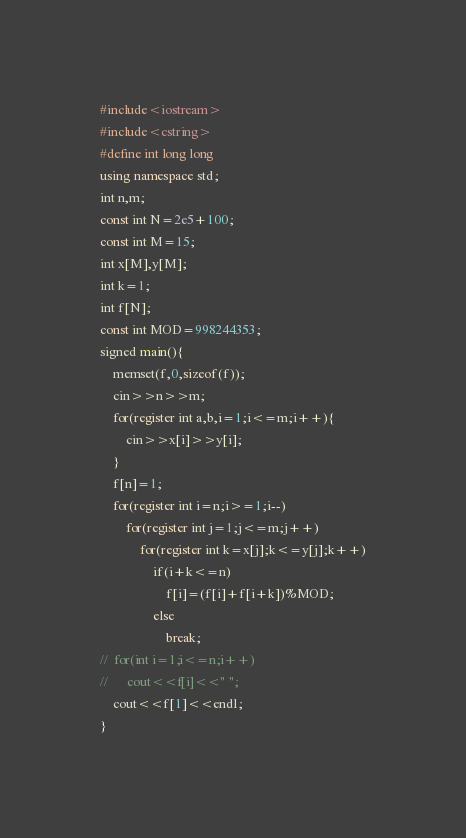Convert code to text. <code><loc_0><loc_0><loc_500><loc_500><_C++_>#include<iostream>
#include<cstring>
#define int long long
using namespace std;
int n,m;
const int N=2e5+100;
const int M=15;
int x[M],y[M];
int k=1;
int f[N];
const int MOD=998244353;
signed main(){
	memset(f,0,sizeof(f));
	cin>>n>>m;
	for(register int a,b,i=1;i<=m;i++){
		cin>>x[i]>>y[i];
	}
	f[n]=1;
	for(register int i=n;i>=1;i--)
		for(register int j=1;j<=m;j++)
			for(register int k=x[j];k<=y[j];k++)
				if(i+k<=n)
					f[i]=(f[i]+f[i+k])%MOD;
				else
					break;
//	for(int i=1;i<=n;i++)
//		cout<<f[i]<<" ";
	cout<<f[1]<<endl;
}



</code> 